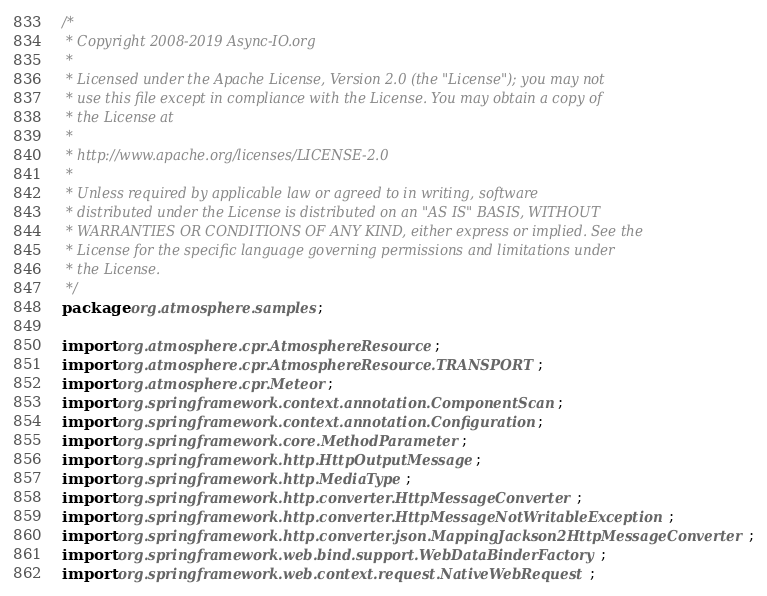<code> <loc_0><loc_0><loc_500><loc_500><_Java_>/*
 * Copyright 2008-2019 Async-IO.org
 *
 * Licensed under the Apache License, Version 2.0 (the "License"); you may not
 * use this file except in compliance with the License. You may obtain a copy of
 * the License at
 *
 * http://www.apache.org/licenses/LICENSE-2.0
 *
 * Unless required by applicable law or agreed to in writing, software
 * distributed under the License is distributed on an "AS IS" BASIS, WITHOUT
 * WARRANTIES OR CONDITIONS OF ANY KIND, either express or implied. See the
 * License for the specific language governing permissions and limitations under
 * the License.
 */
package org.atmosphere.samples;

import org.atmosphere.cpr.AtmosphereResource;
import org.atmosphere.cpr.AtmosphereResource.TRANSPORT;
import org.atmosphere.cpr.Meteor;
import org.springframework.context.annotation.ComponentScan;
import org.springframework.context.annotation.Configuration;
import org.springframework.core.MethodParameter;
import org.springframework.http.HttpOutputMessage;
import org.springframework.http.MediaType;
import org.springframework.http.converter.HttpMessageConverter;
import org.springframework.http.converter.HttpMessageNotWritableException;
import org.springframework.http.converter.json.MappingJackson2HttpMessageConverter;
import org.springframework.web.bind.support.WebDataBinderFactory;
import org.springframework.web.context.request.NativeWebRequest;</code> 